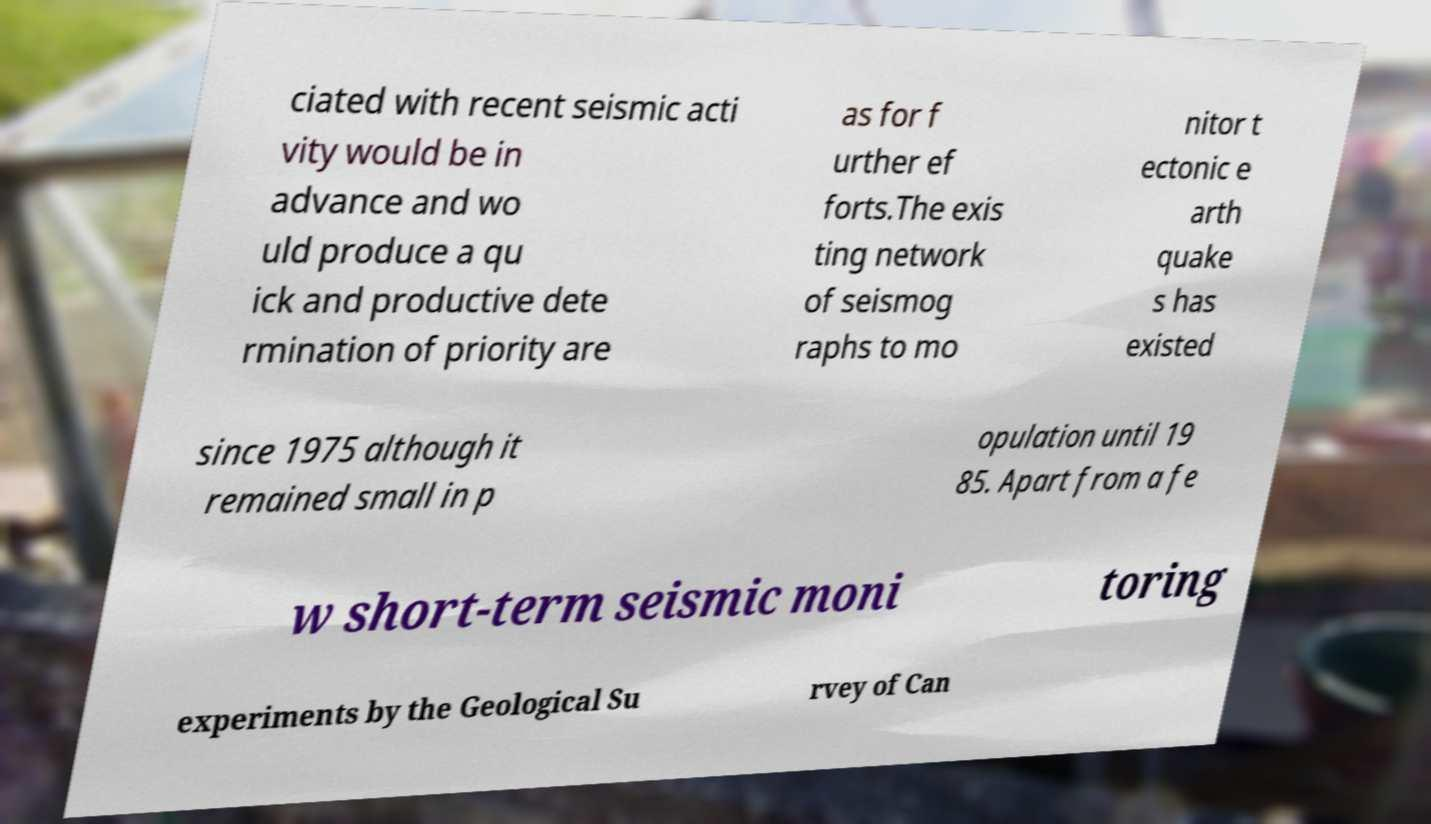Please read and relay the text visible in this image. What does it say? ciated with recent seismic acti vity would be in advance and wo uld produce a qu ick and productive dete rmination of priority are as for f urther ef forts.The exis ting network of seismog raphs to mo nitor t ectonic e arth quake s has existed since 1975 although it remained small in p opulation until 19 85. Apart from a fe w short-term seismic moni toring experiments by the Geological Su rvey of Can 